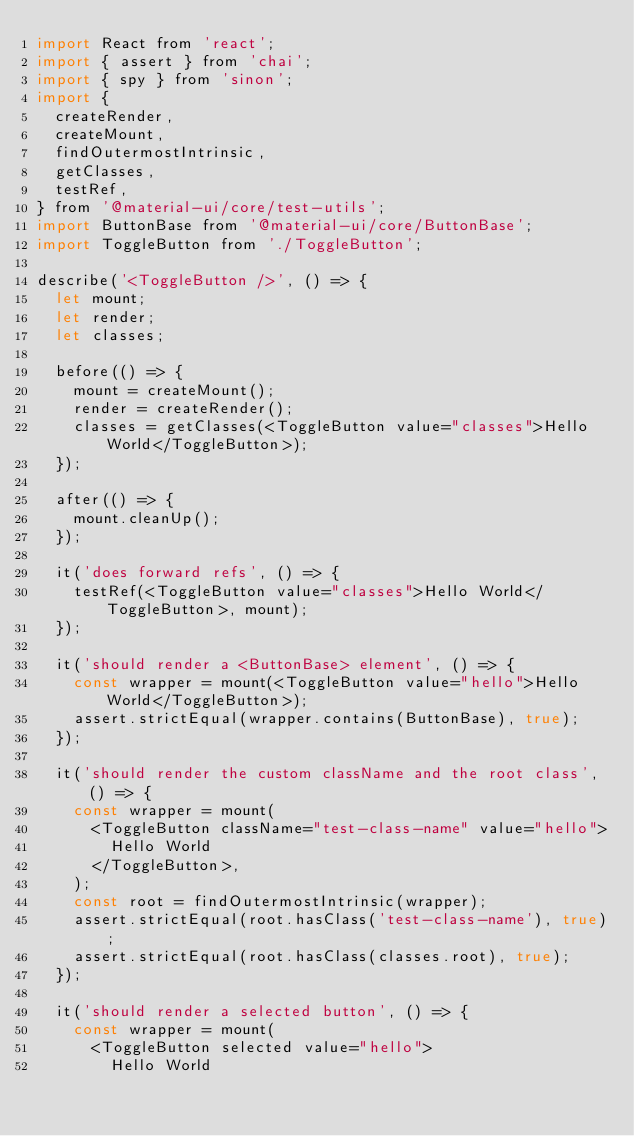<code> <loc_0><loc_0><loc_500><loc_500><_JavaScript_>import React from 'react';
import { assert } from 'chai';
import { spy } from 'sinon';
import {
  createRender,
  createMount,
  findOutermostIntrinsic,
  getClasses,
  testRef,
} from '@material-ui/core/test-utils';
import ButtonBase from '@material-ui/core/ButtonBase';
import ToggleButton from './ToggleButton';

describe('<ToggleButton />', () => {
  let mount;
  let render;
  let classes;

  before(() => {
    mount = createMount();
    render = createRender();
    classes = getClasses(<ToggleButton value="classes">Hello World</ToggleButton>);
  });

  after(() => {
    mount.cleanUp();
  });

  it('does forward refs', () => {
    testRef(<ToggleButton value="classes">Hello World</ToggleButton>, mount);
  });

  it('should render a <ButtonBase> element', () => {
    const wrapper = mount(<ToggleButton value="hello">Hello World</ToggleButton>);
    assert.strictEqual(wrapper.contains(ButtonBase), true);
  });

  it('should render the custom className and the root class', () => {
    const wrapper = mount(
      <ToggleButton className="test-class-name" value="hello">
        Hello World
      </ToggleButton>,
    );
    const root = findOutermostIntrinsic(wrapper);
    assert.strictEqual(root.hasClass('test-class-name'), true);
    assert.strictEqual(root.hasClass(classes.root), true);
  });

  it('should render a selected button', () => {
    const wrapper = mount(
      <ToggleButton selected value="hello">
        Hello World</code> 